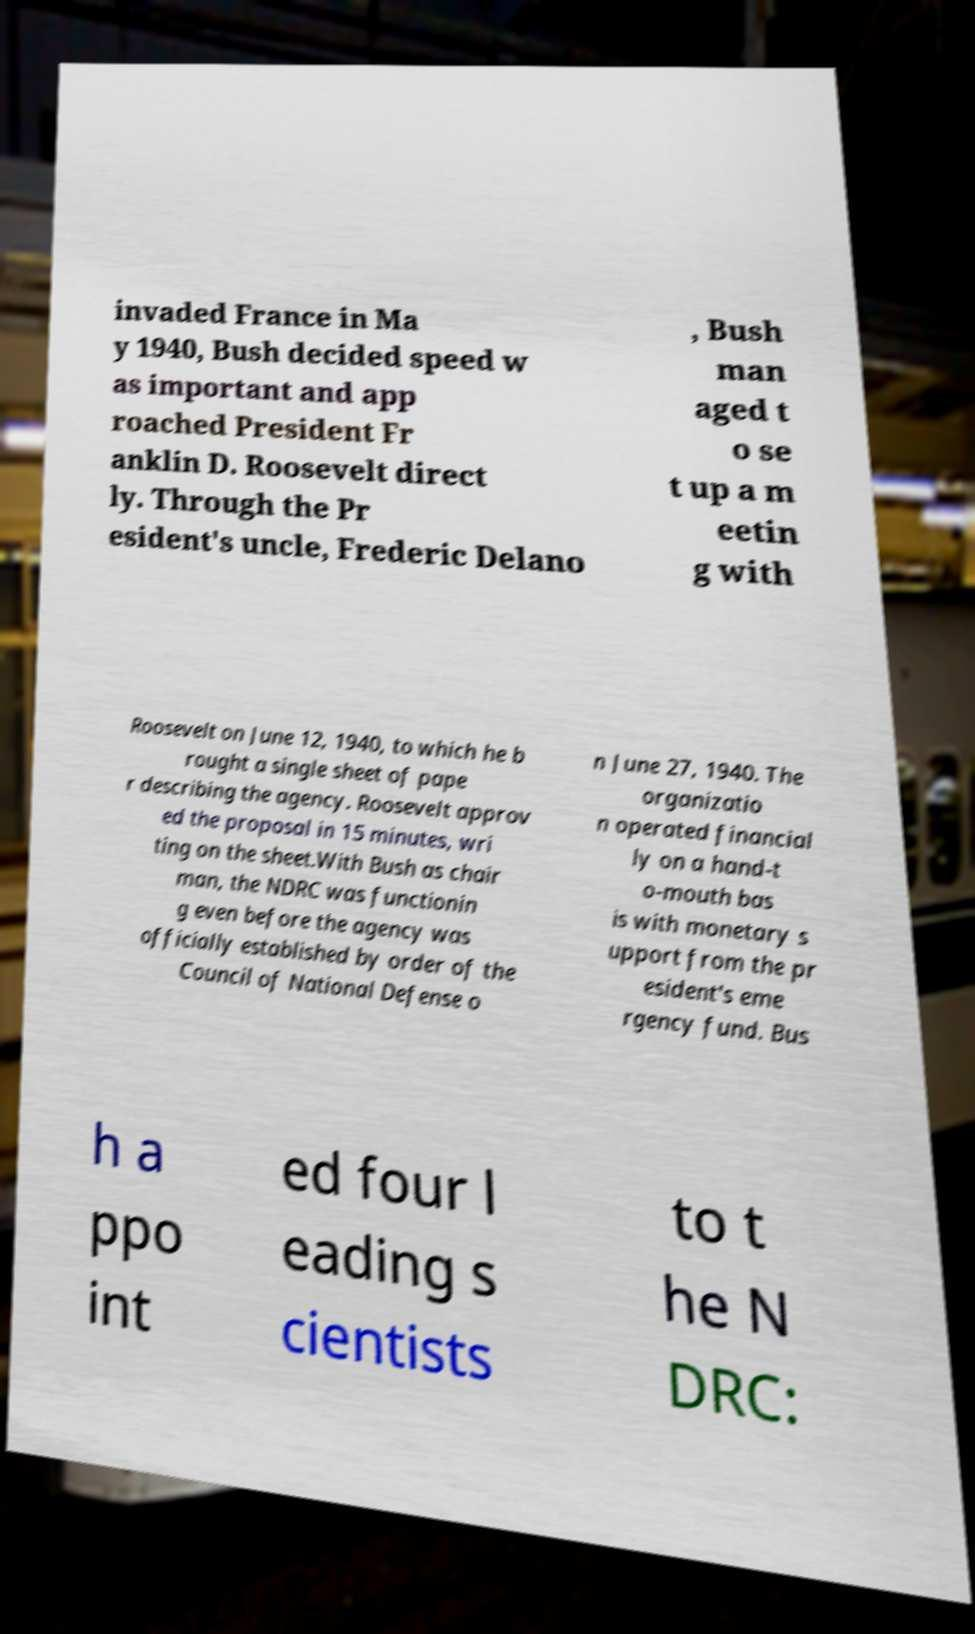What messages or text are displayed in this image? I need them in a readable, typed format. invaded France in Ma y 1940, Bush decided speed w as important and app roached President Fr anklin D. Roosevelt direct ly. Through the Pr esident's uncle, Frederic Delano , Bush man aged t o se t up a m eetin g with Roosevelt on June 12, 1940, to which he b rought a single sheet of pape r describing the agency. Roosevelt approv ed the proposal in 15 minutes, wri ting on the sheet.With Bush as chair man, the NDRC was functionin g even before the agency was officially established by order of the Council of National Defense o n June 27, 1940. The organizatio n operated financial ly on a hand-t o-mouth bas is with monetary s upport from the pr esident's eme rgency fund. Bus h a ppo int ed four l eading s cientists to t he N DRC: 